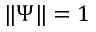<formula> <loc_0><loc_0><loc_500><loc_500>\| \Psi \| = 1</formula> 